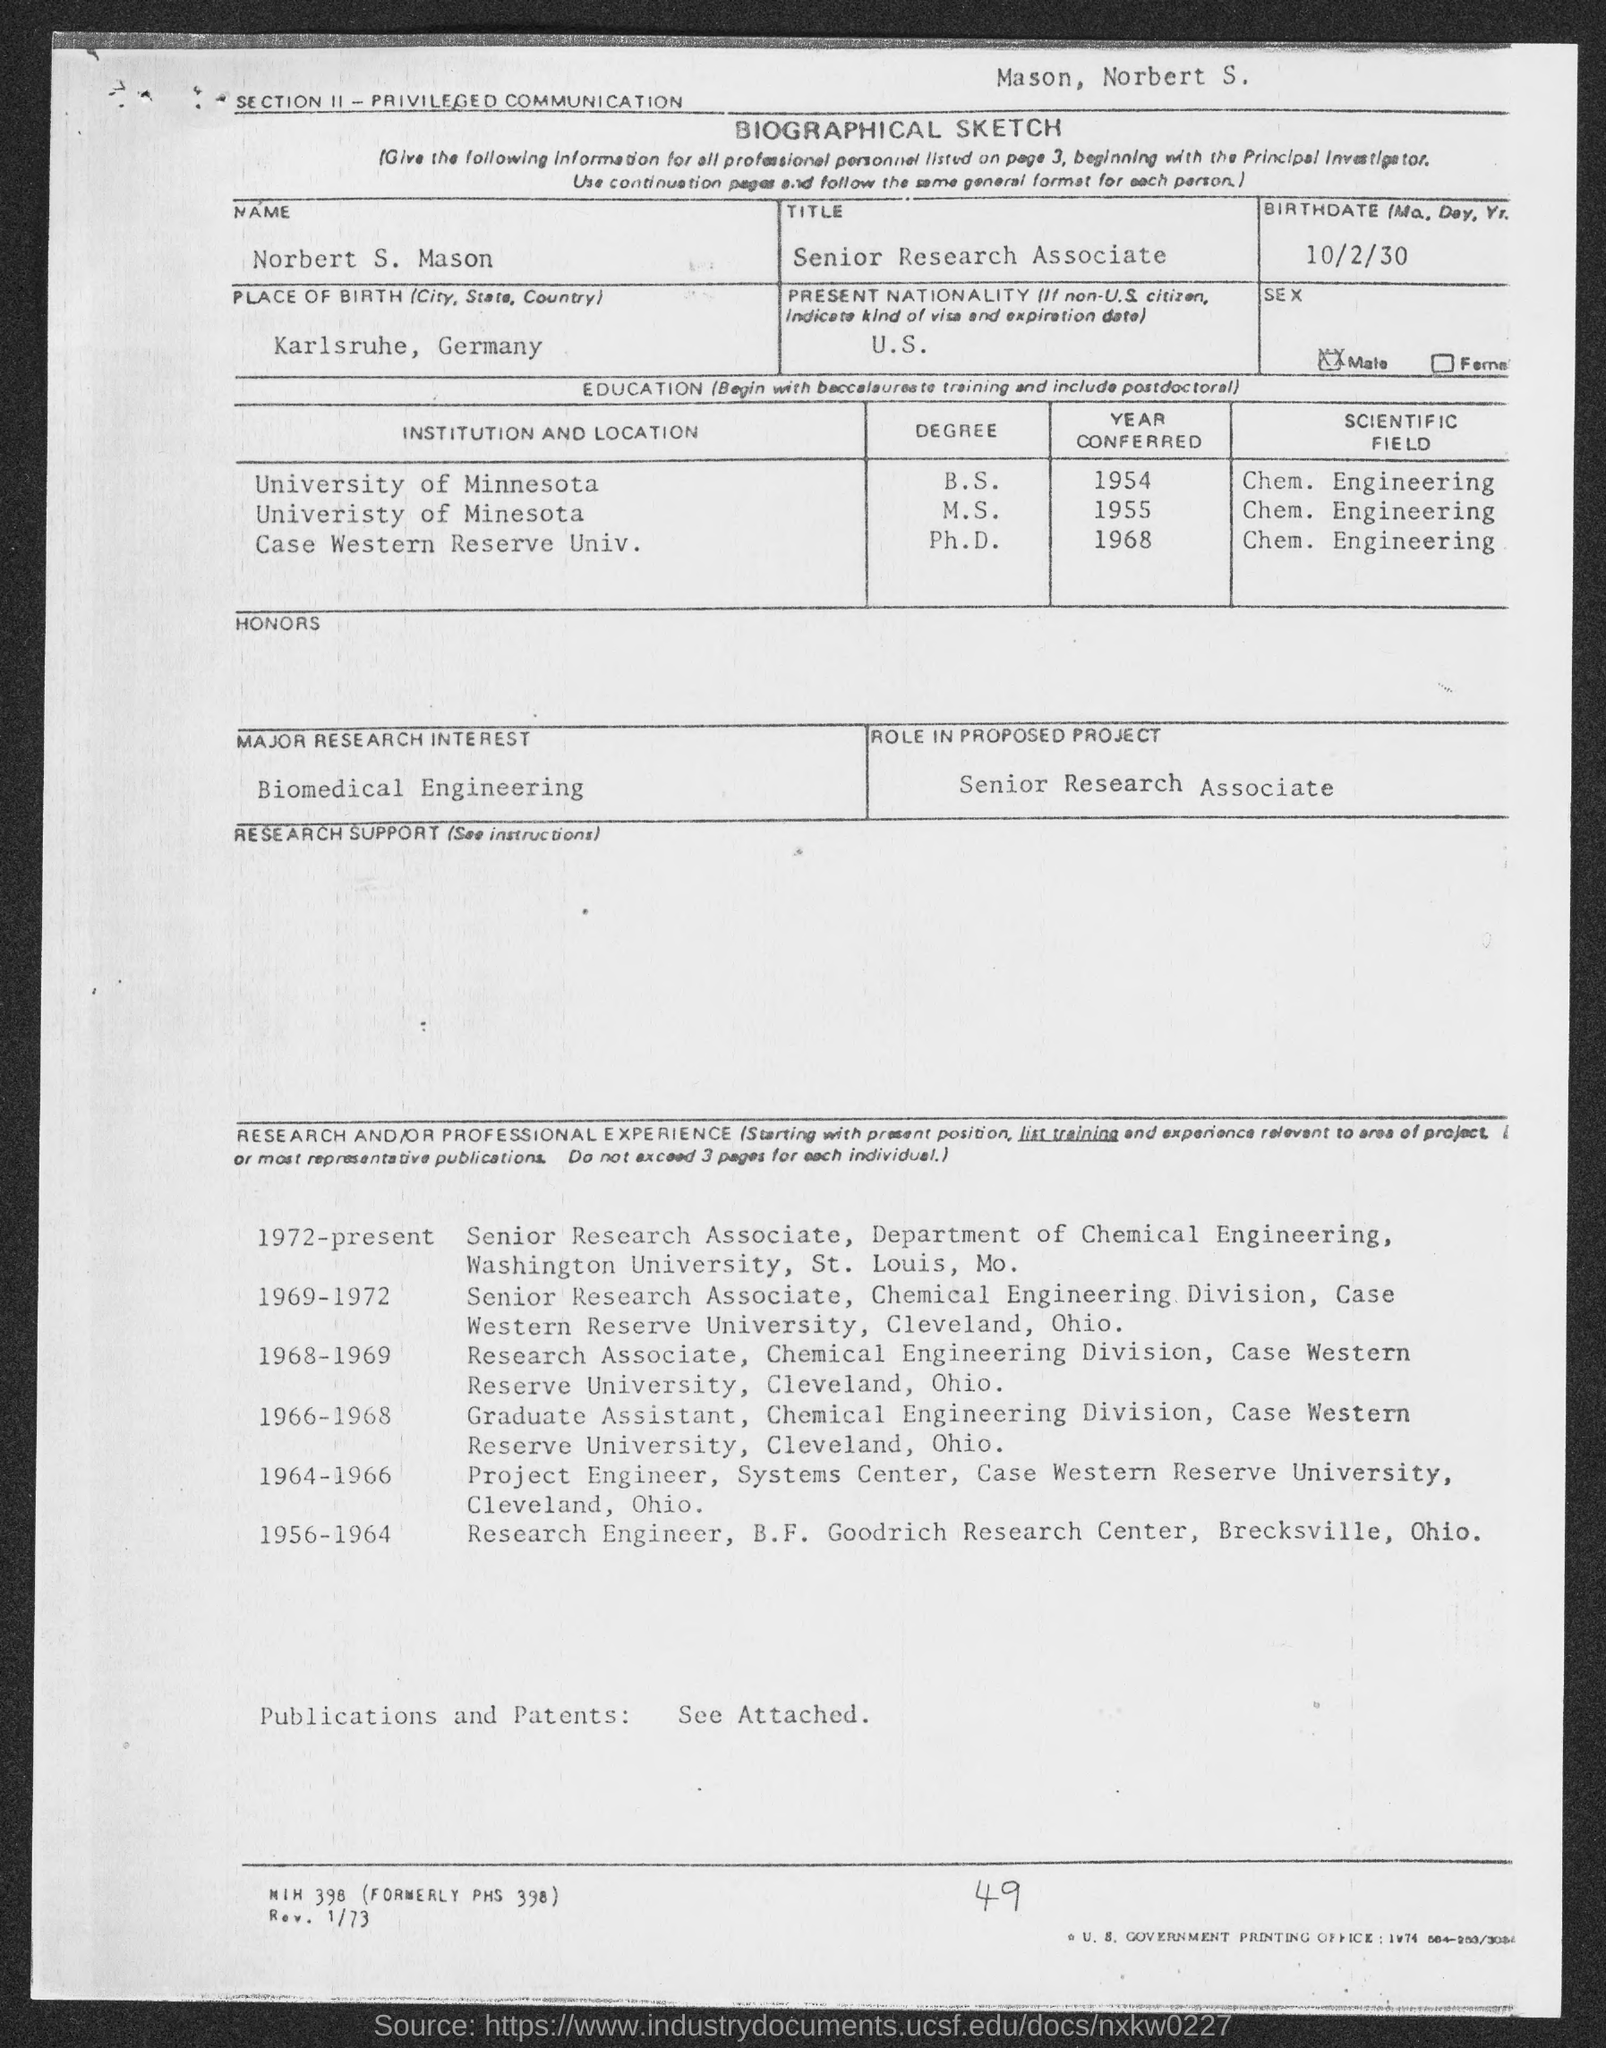What is the name of the candidate in the form?
Give a very brief answer. Norbert S. Mason. What is the title of norbert s. mason ?
Offer a very short reply. Senior Research Associate. What is the birth date of norbert s. mason?
Give a very brief answer. 10/2/30. What is the place of birth of  norbert s. mason?
Give a very brief answer. Karlsruhe, Germany. What is the present nationality of norbert s. mason?
Your answer should be compact. U.S. From which institution did Norbert S.Mason complete his B.S.?
Ensure brevity in your answer.  University of Minnesota. In which year did norbert s. mason complete his b.s. ?
Make the answer very short. 1954. From which institution did Norbert S. Mason complete his Ph.D.?
Give a very brief answer. Case Western Reserve Univ. In which year did norbert s. mason complete his ph.d.?
Offer a terse response. 1968. In which year did norbert s. mason complete his m.s.?
Provide a short and direct response. 1955. 